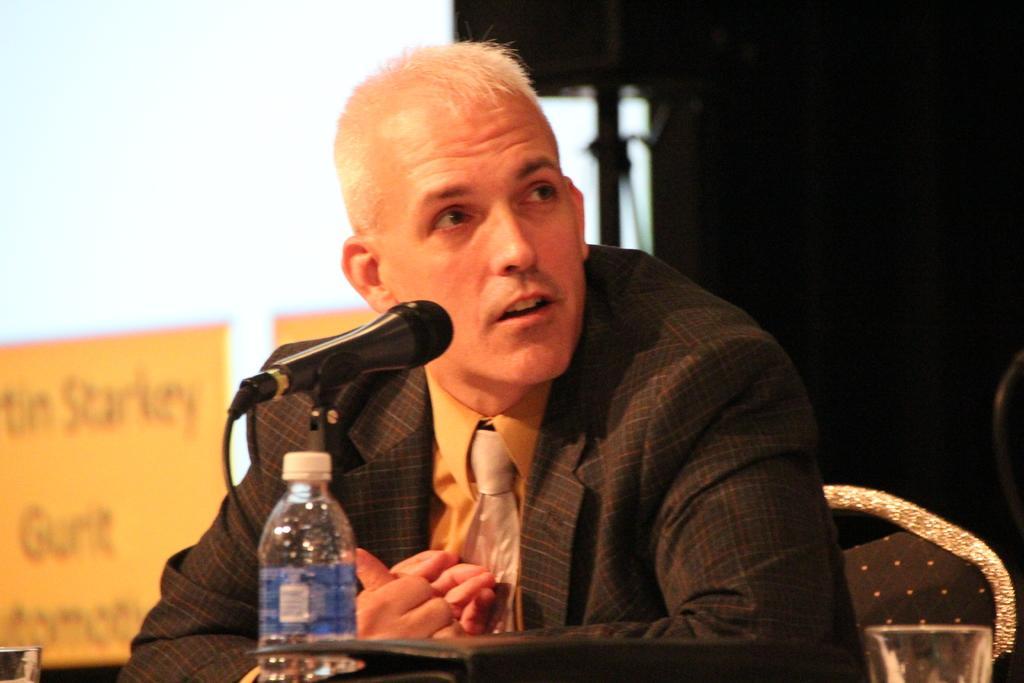Describe this image in one or two sentences. Here is the man with black blazer and yellow t-shirt, with silver color tie. He is talking on a microphone and he is sitting on the chair. In front of him, we see a table on which bottle, file and glass is placed on it. Behind him, we see a chart on which text is written on it. Behind him, we find a wall which is white in color. 